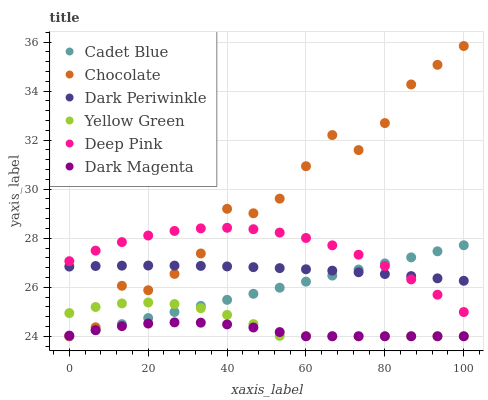Does Dark Magenta have the minimum area under the curve?
Answer yes or no. Yes. Does Chocolate have the maximum area under the curve?
Answer yes or no. Yes. Does Yellow Green have the minimum area under the curve?
Answer yes or no. No. Does Yellow Green have the maximum area under the curve?
Answer yes or no. No. Is Cadet Blue the smoothest?
Answer yes or no. Yes. Is Chocolate the roughest?
Answer yes or no. Yes. Is Yellow Green the smoothest?
Answer yes or no. No. Is Yellow Green the roughest?
Answer yes or no. No. Does Cadet Blue have the lowest value?
Answer yes or no. Yes. Does Deep Pink have the lowest value?
Answer yes or no. No. Does Chocolate have the highest value?
Answer yes or no. Yes. Does Yellow Green have the highest value?
Answer yes or no. No. Is Yellow Green less than Deep Pink?
Answer yes or no. Yes. Is Deep Pink greater than Yellow Green?
Answer yes or no. Yes. Does Chocolate intersect Yellow Green?
Answer yes or no. Yes. Is Chocolate less than Yellow Green?
Answer yes or no. No. Is Chocolate greater than Yellow Green?
Answer yes or no. No. Does Yellow Green intersect Deep Pink?
Answer yes or no. No. 